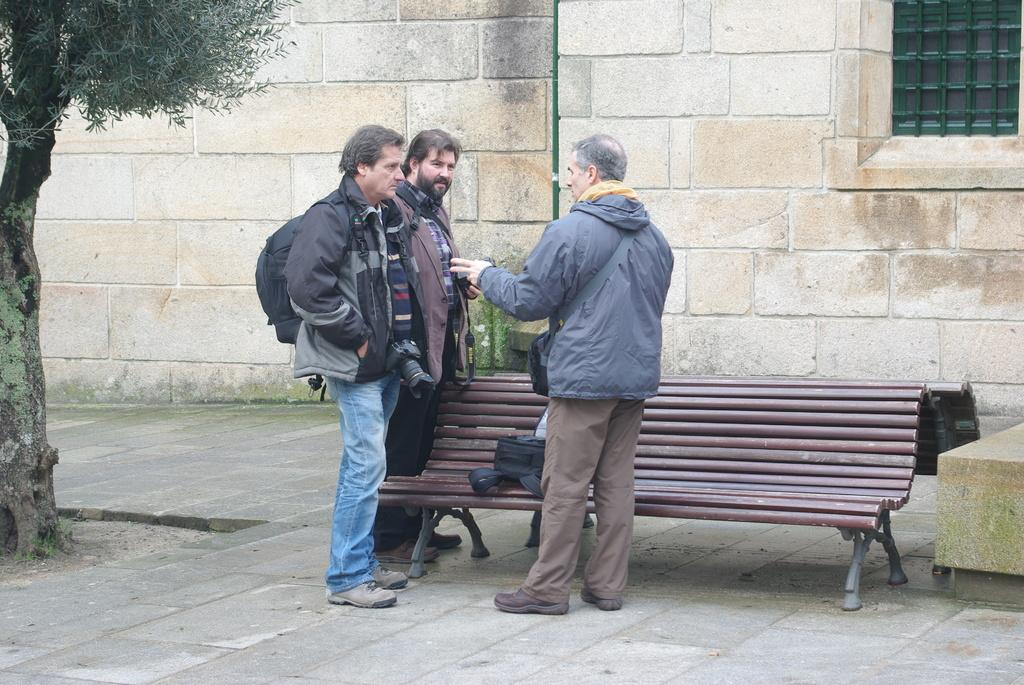How many people are standing on the road in the image? There are three persons standing on the road in the image. What object can be seen in the image that people might sit on? There is a bench in the image. What item is visible in the image that someone might be carrying? There is a bag in the image. What type of structure can be seen in the background of the image? There is a wall in the background of the image. What architectural feature is visible in the background of the image? There is a window in the background of the image. What type of vegetation can be seen in the image? There is a tree visible in the image. What is the opinion of the tree about the weather in the image? Trees do not have opinions, so this question cannot be answered. How does the bag rub against the person's shoulder in the image? The bag does not move or rub against the person's shoulder in the image; it is stationary. 